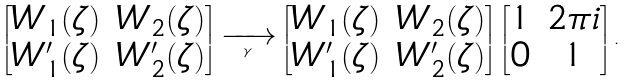Convert formula to latex. <formula><loc_0><loc_0><loc_500><loc_500>\begin{bmatrix} W _ { 1 } ( \zeta ) & W _ { 2 } ( \zeta ) \\ W _ { 1 } ^ { \prime } ( \zeta ) & W _ { 2 } ^ { \prime } ( \zeta ) \end{bmatrix} \xrightarrow [ \gamma ] { \quad } \begin{bmatrix} W _ { 1 } ( \zeta ) & W _ { 2 } ( \zeta ) \\ W _ { 1 } ^ { \prime } ( \zeta ) & W _ { 2 } ^ { \prime } ( \zeta ) \end{bmatrix} \begin{bmatrix} 1 & 2 \pi i \\ 0 & 1 \end{bmatrix} .</formula> 